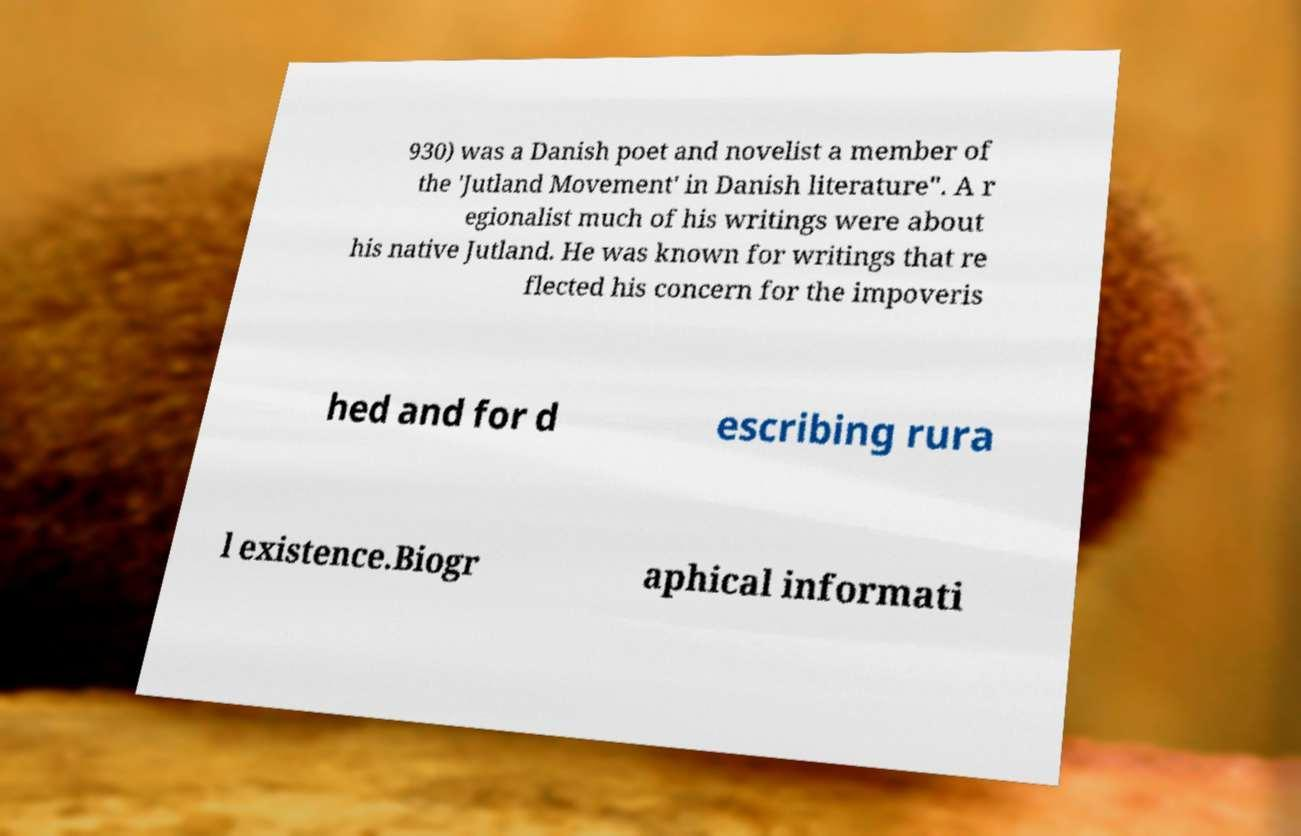What messages or text are displayed in this image? I need them in a readable, typed format. 930) was a Danish poet and novelist a member of the 'Jutland Movement' in Danish literature". A r egionalist much of his writings were about his native Jutland. He was known for writings that re flected his concern for the impoveris hed and for d escribing rura l existence.Biogr aphical informati 